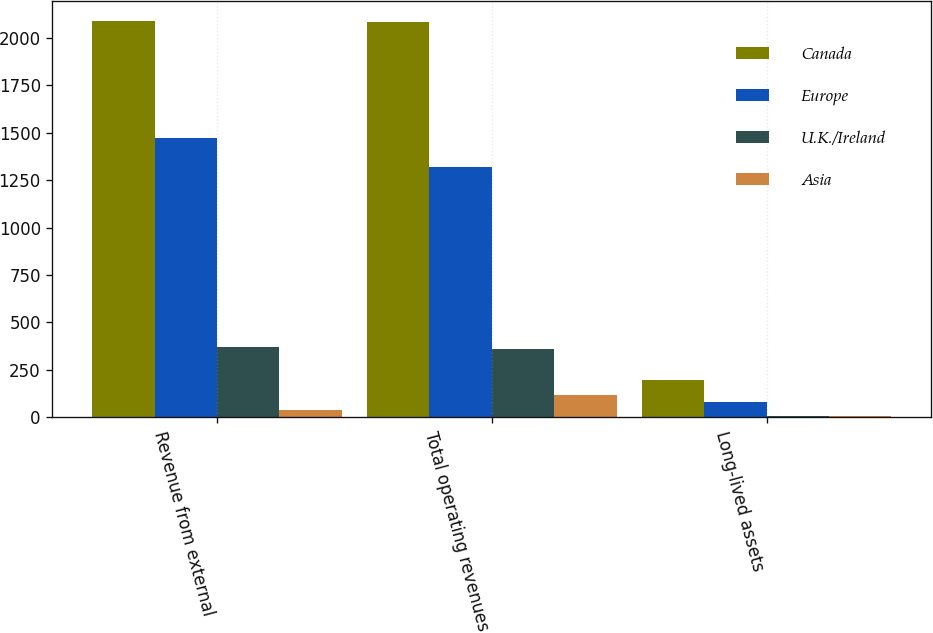Convert chart to OTSL. <chart><loc_0><loc_0><loc_500><loc_500><stacked_bar_chart><ecel><fcel>Revenue from external<fcel>Total operating revenues<fcel>Long-lived assets<nl><fcel>Canada<fcel>2090.2<fcel>2082.1<fcel>196.7<nl><fcel>Europe<fcel>1473.1<fcel>1320.3<fcel>81.5<nl><fcel>U.K./Ireland<fcel>372.3<fcel>358.2<fcel>7.9<nl><fcel>Asia<fcel>38.8<fcel>115.5<fcel>4.9<nl></chart> 